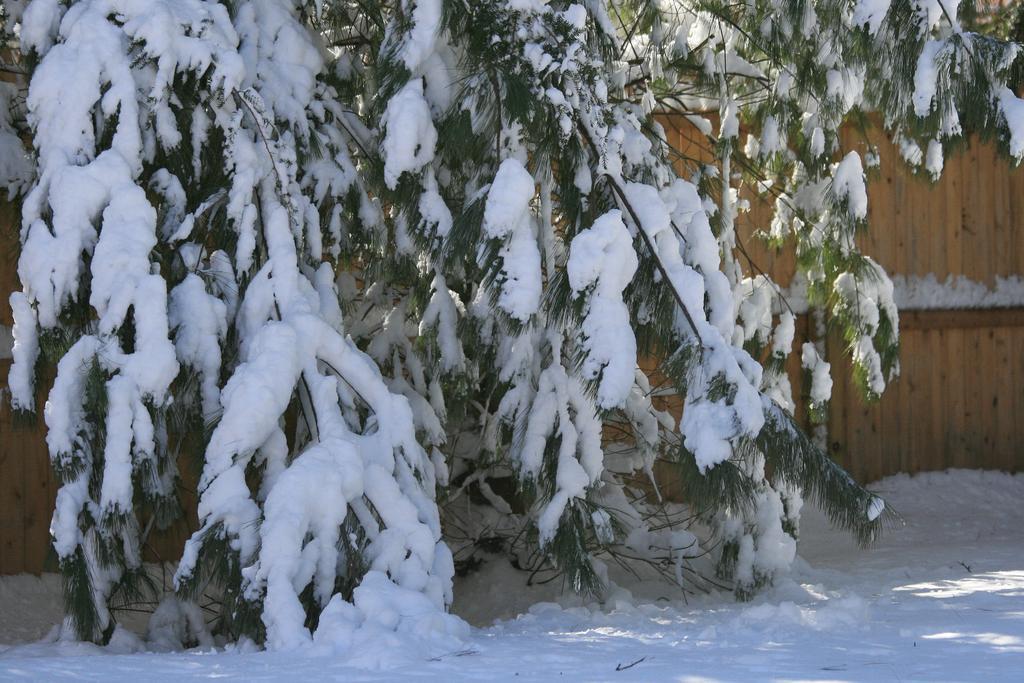How would you summarize this image in a sentence or two? In this image, we can see some snow on the tree. There is a wooden wall on the right side of the image. 